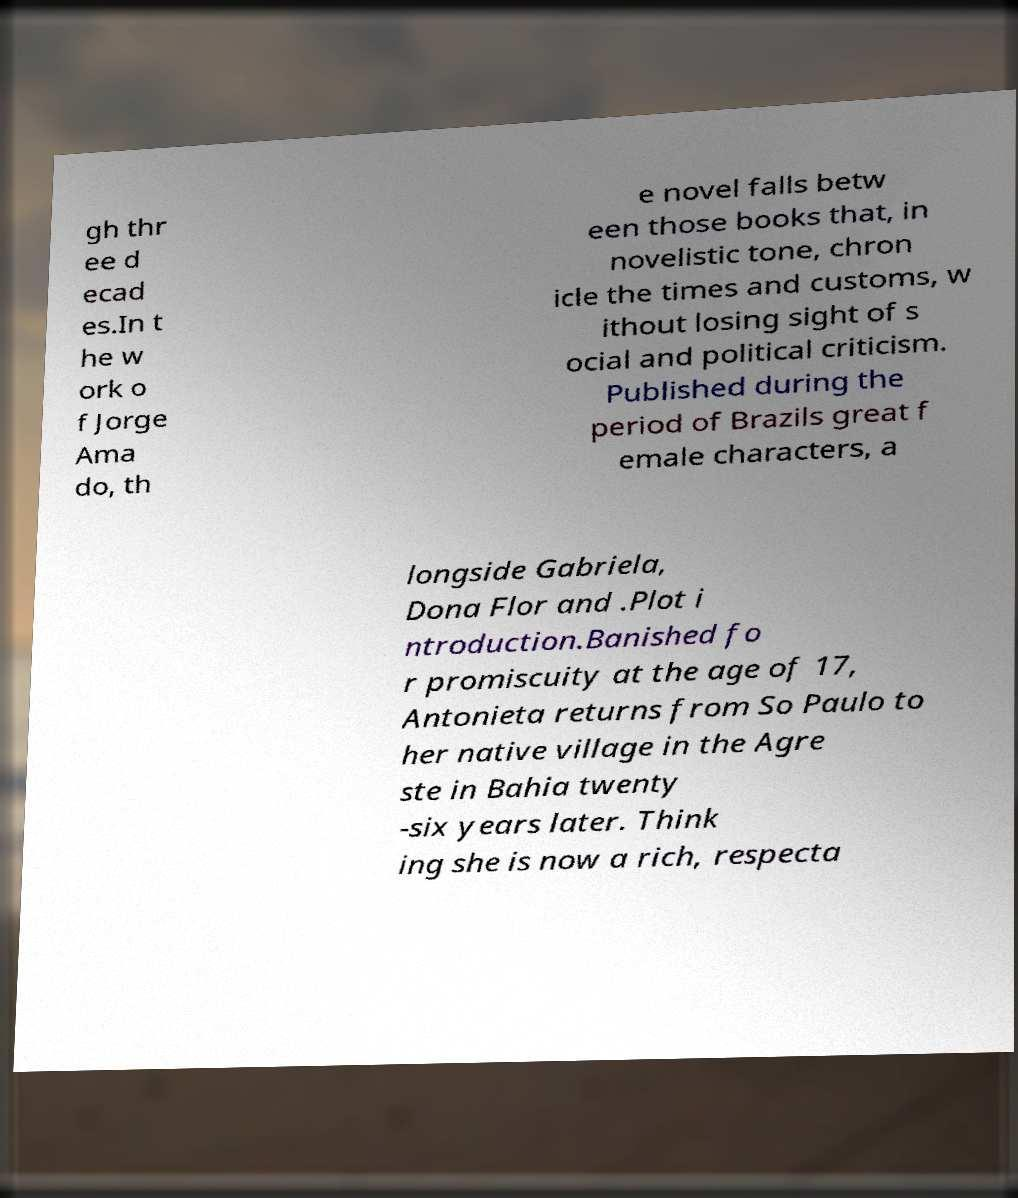Could you extract and type out the text from this image? gh thr ee d ecad es.In t he w ork o f Jorge Ama do, th e novel falls betw een those books that, in novelistic tone, chron icle the times and customs, w ithout losing sight of s ocial and political criticism. Published during the period of Brazils great f emale characters, a longside Gabriela, Dona Flor and .Plot i ntroduction.Banished fo r promiscuity at the age of 17, Antonieta returns from So Paulo to her native village in the Agre ste in Bahia twenty -six years later. Think ing she is now a rich, respecta 